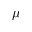<formula> <loc_0><loc_0><loc_500><loc_500>\mu</formula> 